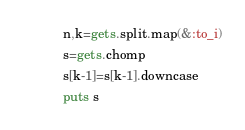<code> <loc_0><loc_0><loc_500><loc_500><_Ruby_>n,k=gets.split.map(&:to_i)
s=gets.chomp
s[k-1]=s[k-1].downcase
puts s</code> 